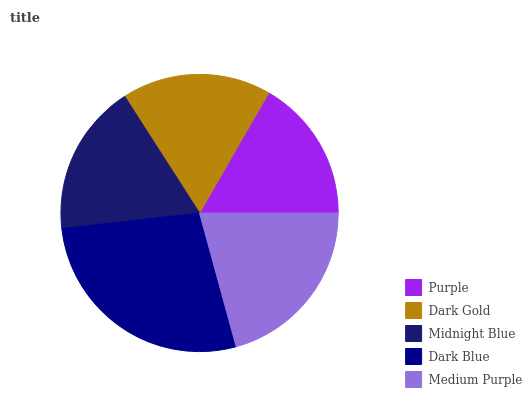Is Purple the minimum?
Answer yes or no. Yes. Is Dark Blue the maximum?
Answer yes or no. Yes. Is Dark Gold the minimum?
Answer yes or no. No. Is Dark Gold the maximum?
Answer yes or no. No. Is Dark Gold greater than Purple?
Answer yes or no. Yes. Is Purple less than Dark Gold?
Answer yes or no. Yes. Is Purple greater than Dark Gold?
Answer yes or no. No. Is Dark Gold less than Purple?
Answer yes or no. No. Is Midnight Blue the high median?
Answer yes or no. Yes. Is Midnight Blue the low median?
Answer yes or no. Yes. Is Dark Blue the high median?
Answer yes or no. No. Is Dark Blue the low median?
Answer yes or no. No. 